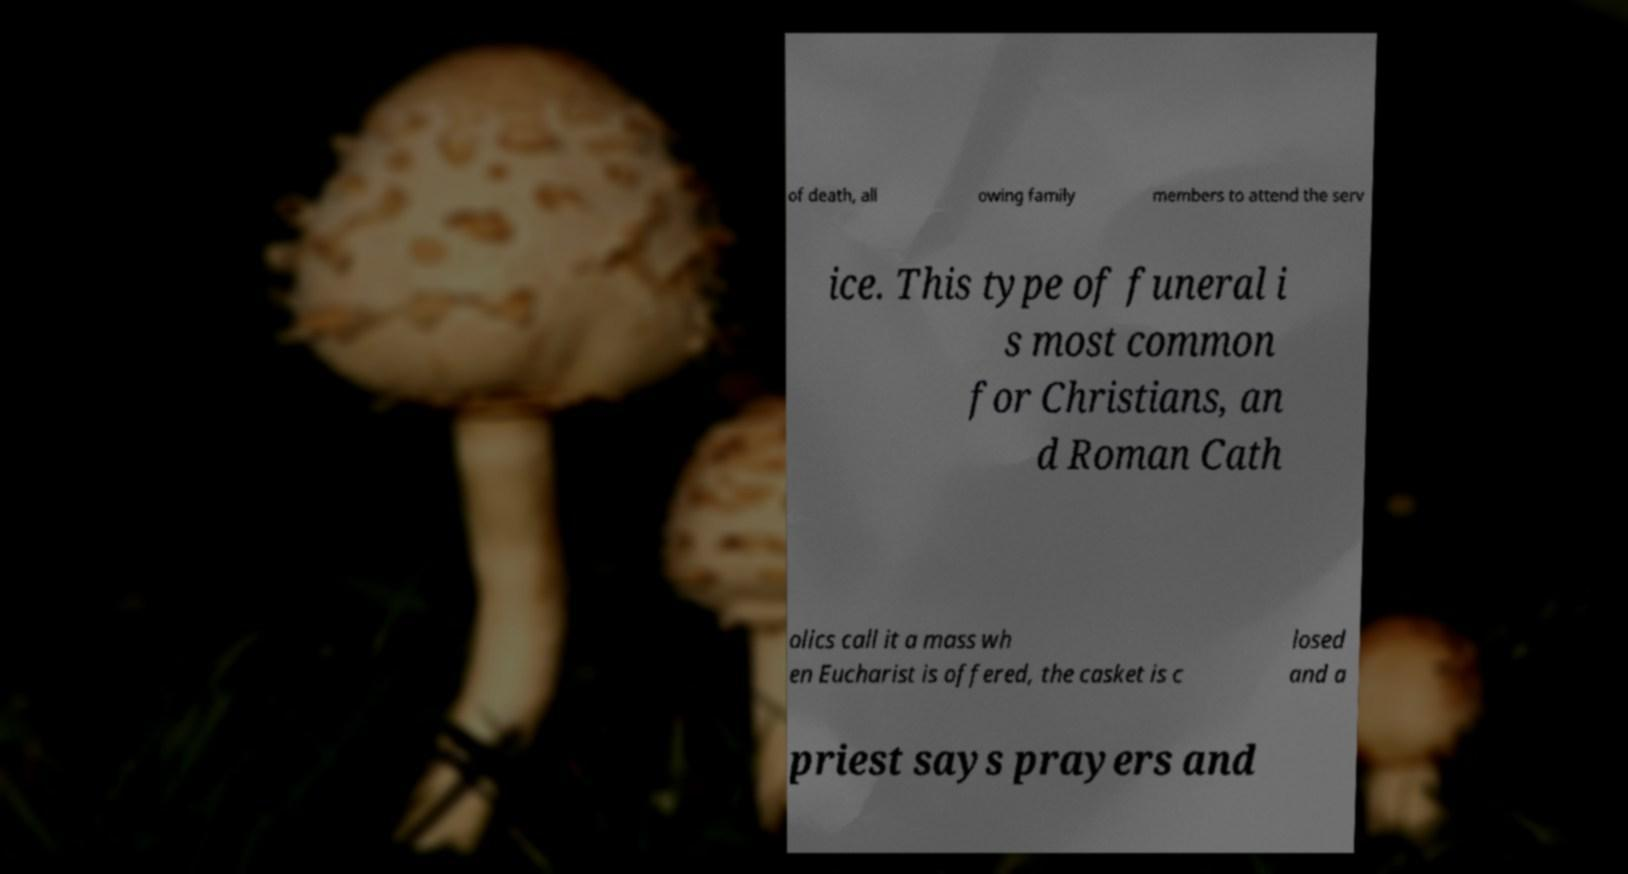Can you read and provide the text displayed in the image?This photo seems to have some interesting text. Can you extract and type it out for me? of death, all owing family members to attend the serv ice. This type of funeral i s most common for Christians, an d Roman Cath olics call it a mass wh en Eucharist is offered, the casket is c losed and a priest says prayers and 